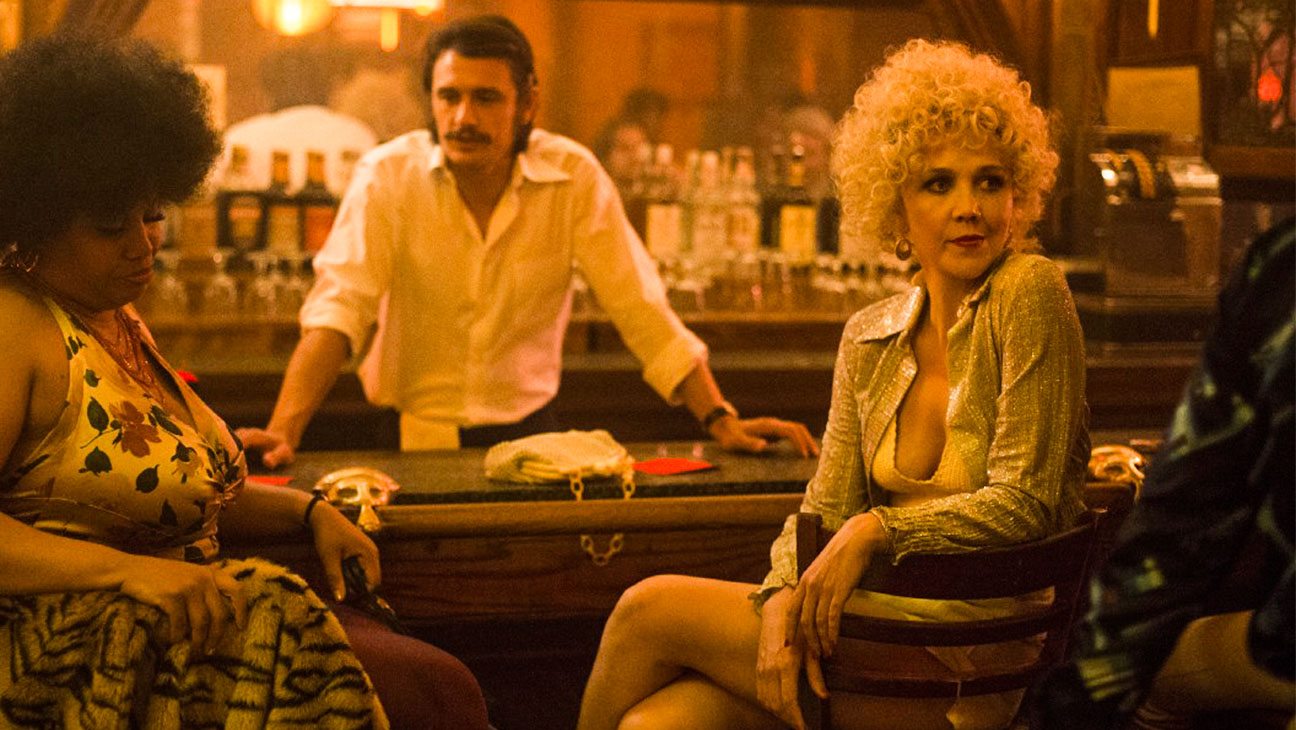What are the key elements in this picture? In this image, we see the actress Maggie Gyllenhaal, known for her role as Eileen "Candy" Merrell in the movie "The Deuce". She is seated on a bar stool in a dimly lit bar, exuding an air of casual confidence. In her hand, she holds a lit cigarette, the glow adding to the subdued lighting of the scene. She is dressed in a striking gold sequin jacket that catches the light, and her hair is styled in a curly blonde wig that frames her face. To her left, there's a woman sporting an afro hairstyle, and to her right, a man with a mustache can be seen. In the background, the bartender is going about his duties, adding to the authentic feel of the bar setting. 